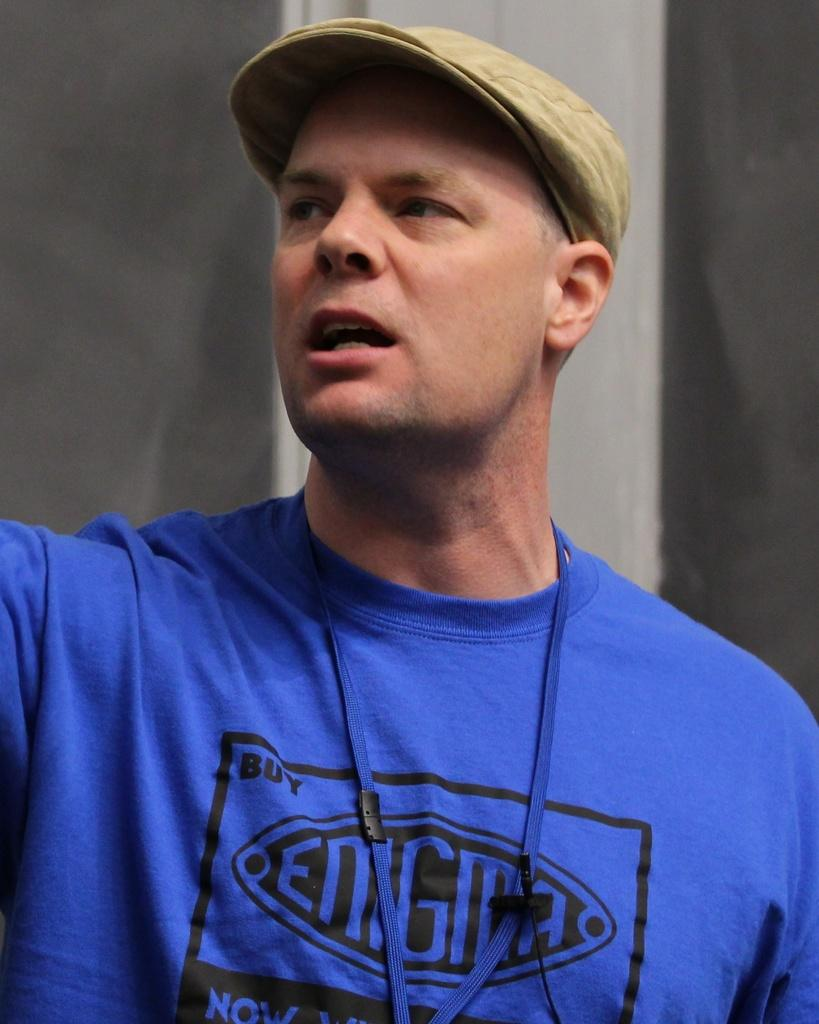<image>
Give a short and clear explanation of the subsequent image. A man in a cap wearing a blue enigma shirt. 